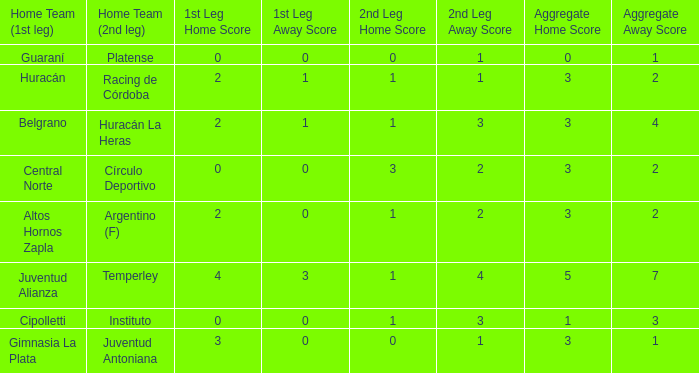Which team played their first leg at home with an aggregate score of 3-4? Belgrano. Give me the full table as a dictionary. {'header': ['Home Team (1st leg)', 'Home Team (2nd leg)', '1st Leg Home Score', '1st Leg Away Score', '2nd Leg Home Score', '2nd Leg Away Score', 'Aggregate Home Score', 'Aggregate Away Score'], 'rows': [['Guaraní', 'Platense', '0', '0', '0', '1', '0', '1'], ['Huracán', 'Racing de Córdoba', '2', '1', '1', '1', '3', '2'], ['Belgrano', 'Huracán La Heras', '2', '1', '1', '3', '3', '4'], ['Central Norte', 'Círculo Deportivo', '0', '0', '3', '2', '3', '2'], ['Altos Hornos Zapla', 'Argentino (F)', '2', '0', '1', '2', '3', '2'], ['Juventud Alianza', 'Temperley', '4', '3', '1', '4', '5', '7'], ['Cipolletti', 'Instituto', '0', '0', '1', '3', '1', '3'], ['Gimnasia La Plata', 'Juventud Antoniana', '3', '0', '0', '1', '3', '1']]} 